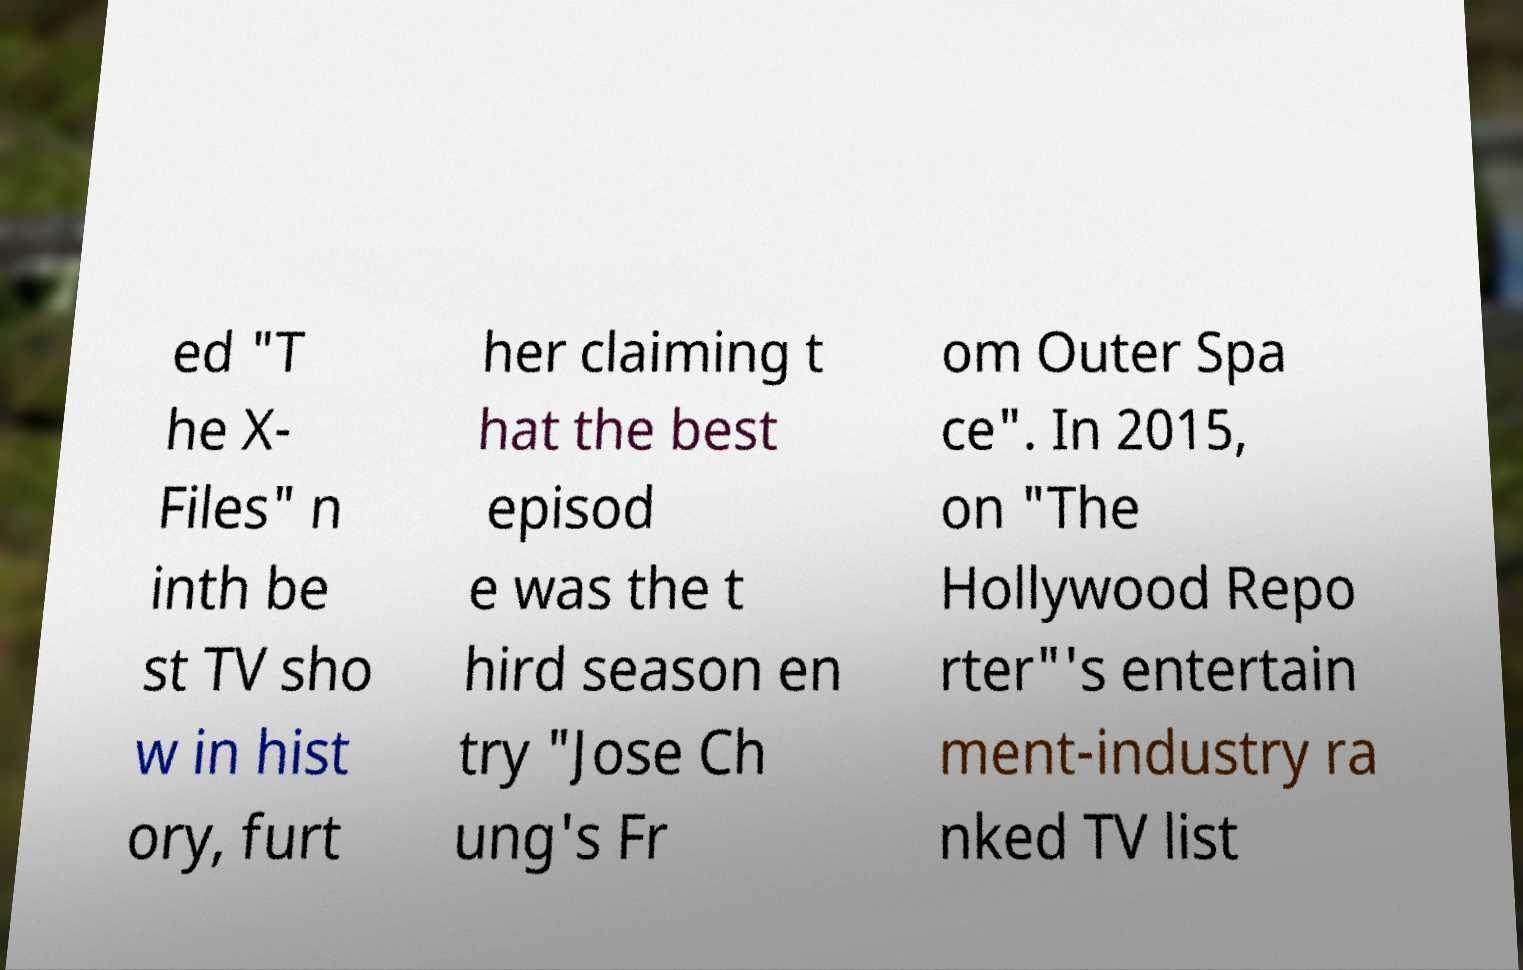For documentation purposes, I need the text within this image transcribed. Could you provide that? ed "T he X- Files" n inth be st TV sho w in hist ory, furt her claiming t hat the best episod e was the t hird season en try "Jose Ch ung's Fr om Outer Spa ce". In 2015, on "The Hollywood Repo rter"'s entertain ment-industry ra nked TV list 